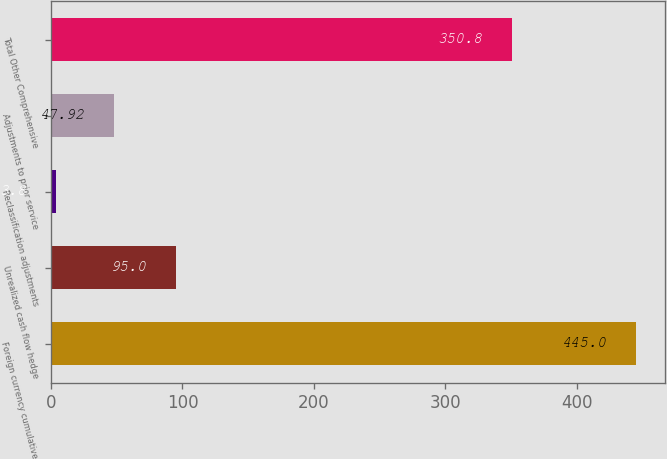Convert chart. <chart><loc_0><loc_0><loc_500><loc_500><bar_chart><fcel>Foreign currency cumulative<fcel>Unrealized cash flow hedge<fcel>Reclassification adjustments<fcel>Adjustments to prior service<fcel>Total Other Comprehensive<nl><fcel>445<fcel>95<fcel>3.8<fcel>47.92<fcel>350.8<nl></chart> 